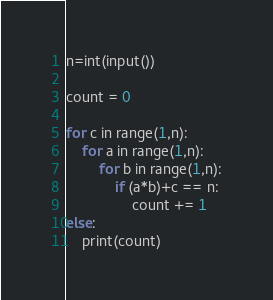Convert code to text. <code><loc_0><loc_0><loc_500><loc_500><_Python_>n=int(input())

count = 0

for c in range(1,n):
    for a in range(1,n):
        for b in range(1,n):
            if (a*b)+c == n:
                count += 1
else:
    print(count)</code> 